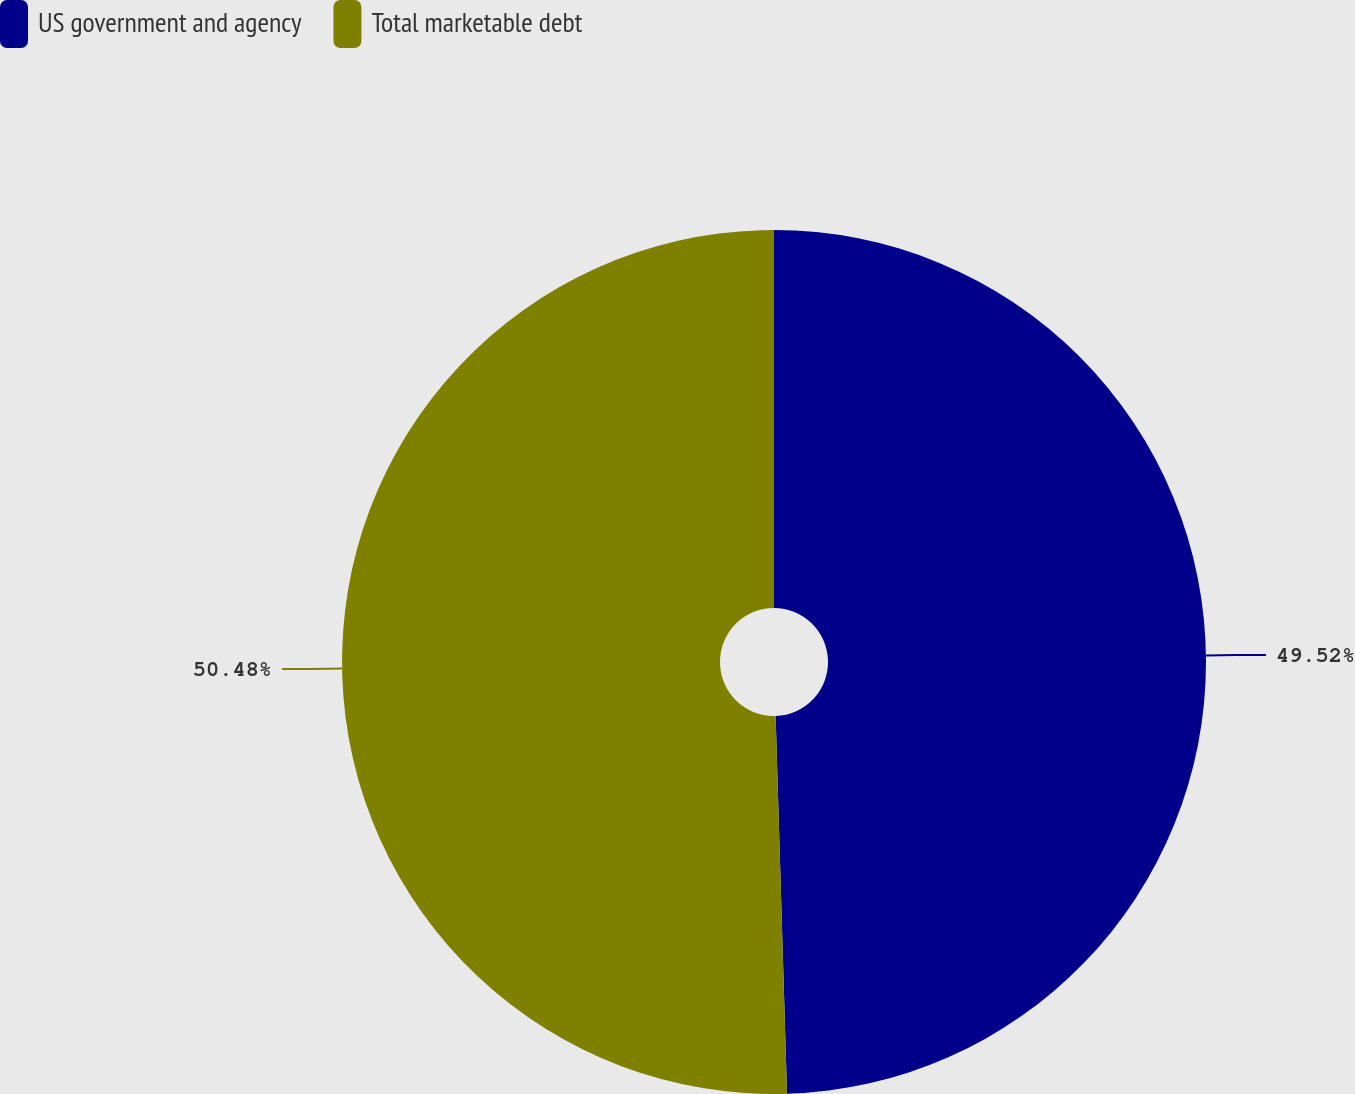Convert chart. <chart><loc_0><loc_0><loc_500><loc_500><pie_chart><fcel>US government and agency<fcel>Total marketable debt<nl><fcel>49.52%<fcel>50.48%<nl></chart> 